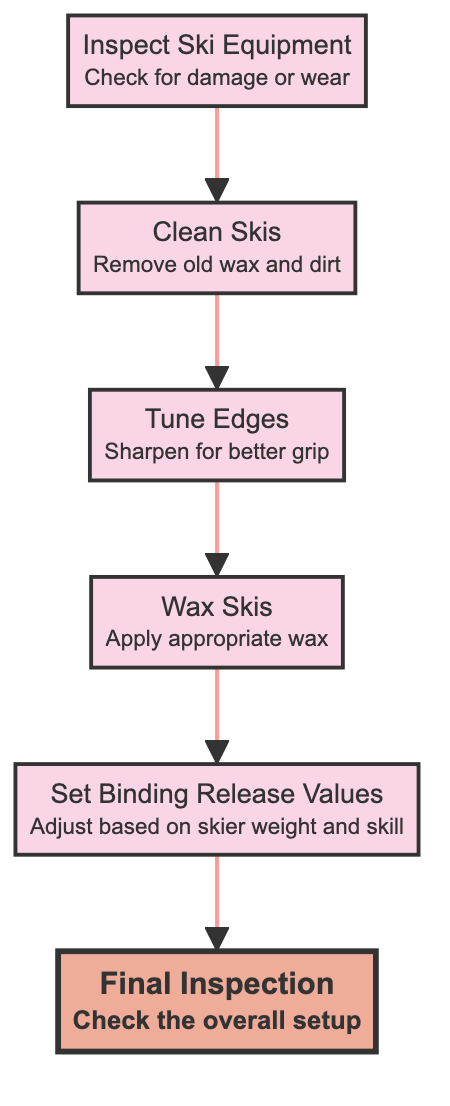What is the first step in the ski equipment maintenance process? The first step can be found at the bottom of the flow chart, which shows the starting process as "Inspect Ski Equipment."
Answer: Inspect Ski Equipment How many total processes are in the diagram? By counting all distinct process nodes in the diagram, we find six: Inspect Ski Equipment, Clean Skis, Tune Edges, Wax Skis, Set Binding Release Values, and Final Inspection.
Answer: 6 Which process follows after "Clean Skis"? The diagram indicates that after "Clean Skis," the next step in the flow is "Tune Edges."
Answer: Tune Edges What action needs to be taken after "Wax Skis"? According to the flow chart, the action following "Wax Skis" is to "Set Binding Release Values."
Answer: Set Binding Release Values What is the final step in the process? The last node at the top of the flow chart, representing the conclusion of the maintenance process, is "Final Inspection."
Answer: Final Inspection How are the edges of the diagram linked visually? The edges connecting the processes are drawn in red, indicating the flow direction from one process to the next.
Answer: Red What do you adjust in the "Set Binding Release Values" step? In this step, the adjustment made is based on skier weight and skill level, as outlined in the details of that process node.
Answer: Release settings What is required before waxing the skis? The maintenance process requires that skis be cleaned prior to applying wax as indicated in the flow of the diagram.
Answer: Clean Skis Which process directly precedes the "Final Inspection"? The "Set Binding Release Values" node is directly before the "Final Inspection" step in the maintenance workflow.
Answer: Set Binding Release Values 